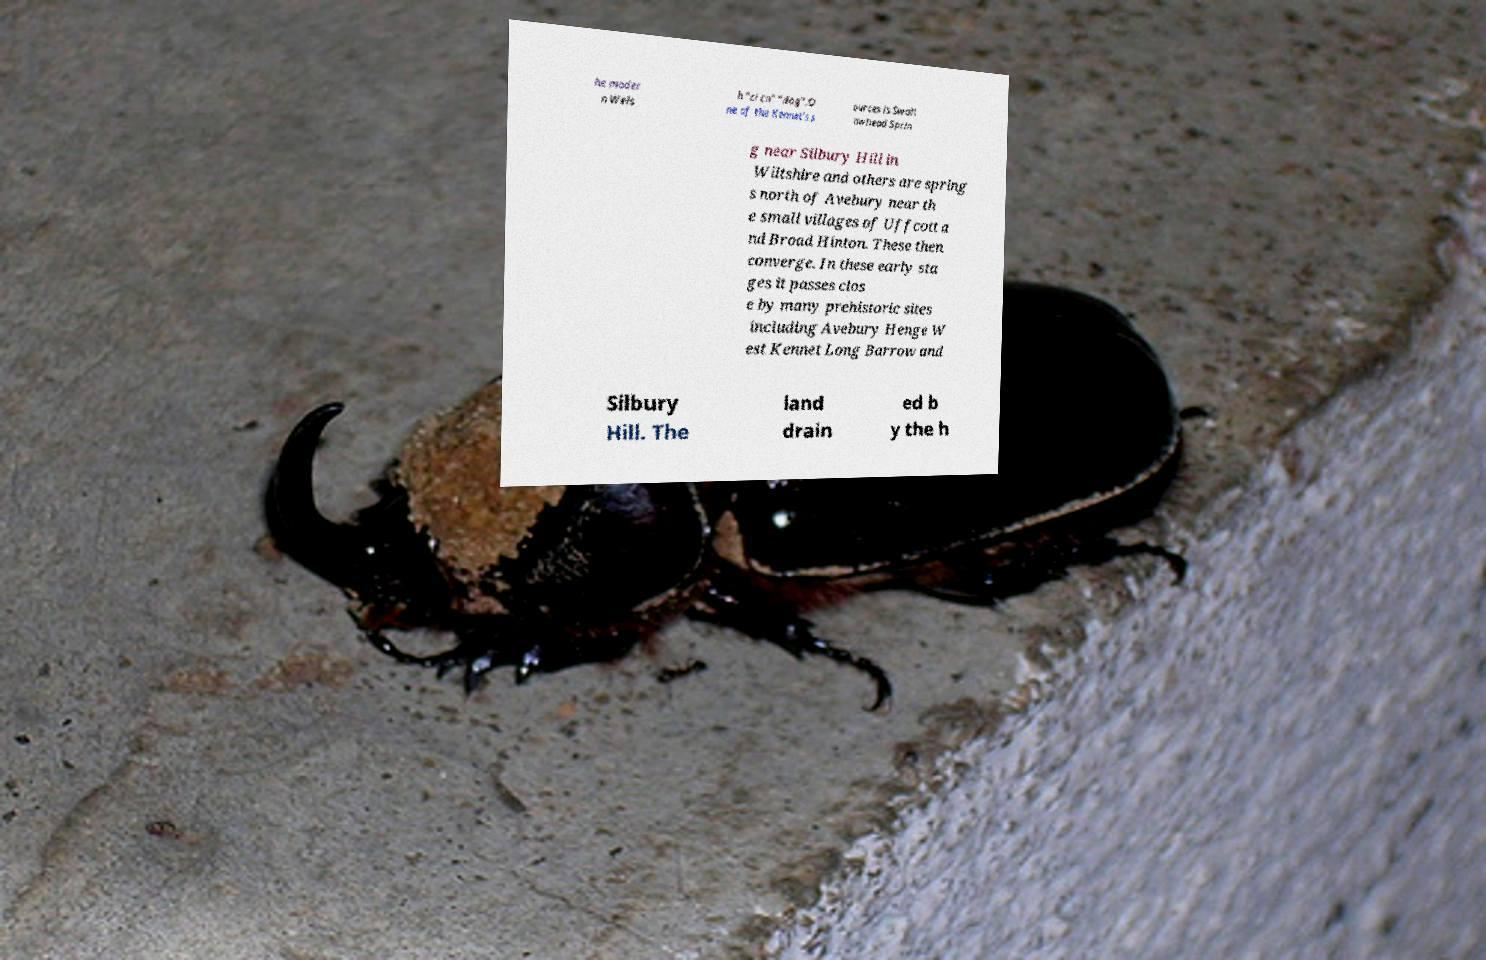Can you accurately transcribe the text from the provided image for me? he moder n Wels h "ci cn" “dog”.O ne of the Kennet's s ources is Swall owhead Sprin g near Silbury Hill in Wiltshire and others are spring s north of Avebury near th e small villages of Uffcott a nd Broad Hinton. These then converge. In these early sta ges it passes clos e by many prehistoric sites including Avebury Henge W est Kennet Long Barrow and Silbury Hill. The land drain ed b y the h 